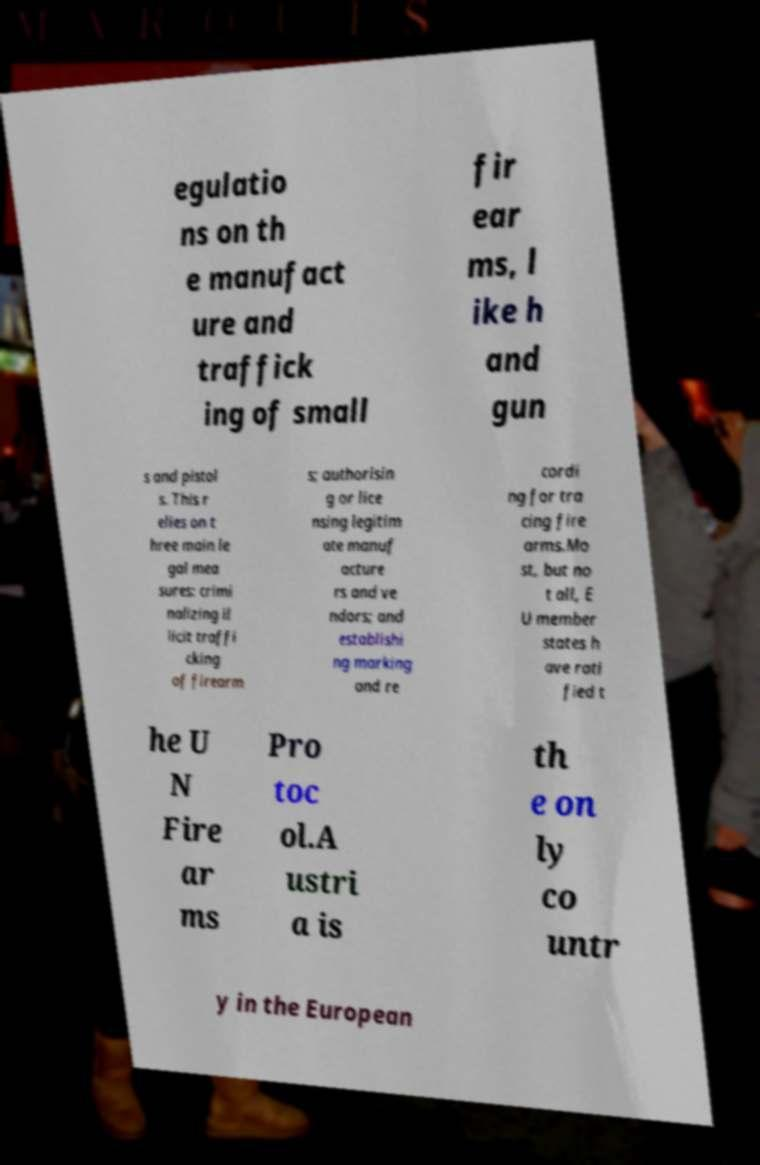There's text embedded in this image that I need extracted. Can you transcribe it verbatim? egulatio ns on th e manufact ure and traffick ing of small fir ear ms, l ike h and gun s and pistol s. This r elies on t hree main le gal mea sures: crimi nalizing il licit traffi cking of firearm s; authorisin g or lice nsing legitim ate manuf acture rs and ve ndors; and establishi ng marking and re cordi ng for tra cing fire arms.Mo st, but no t all, E U member states h ave rati fied t he U N Fire ar ms Pro toc ol.A ustri a is th e on ly co untr y in the European 